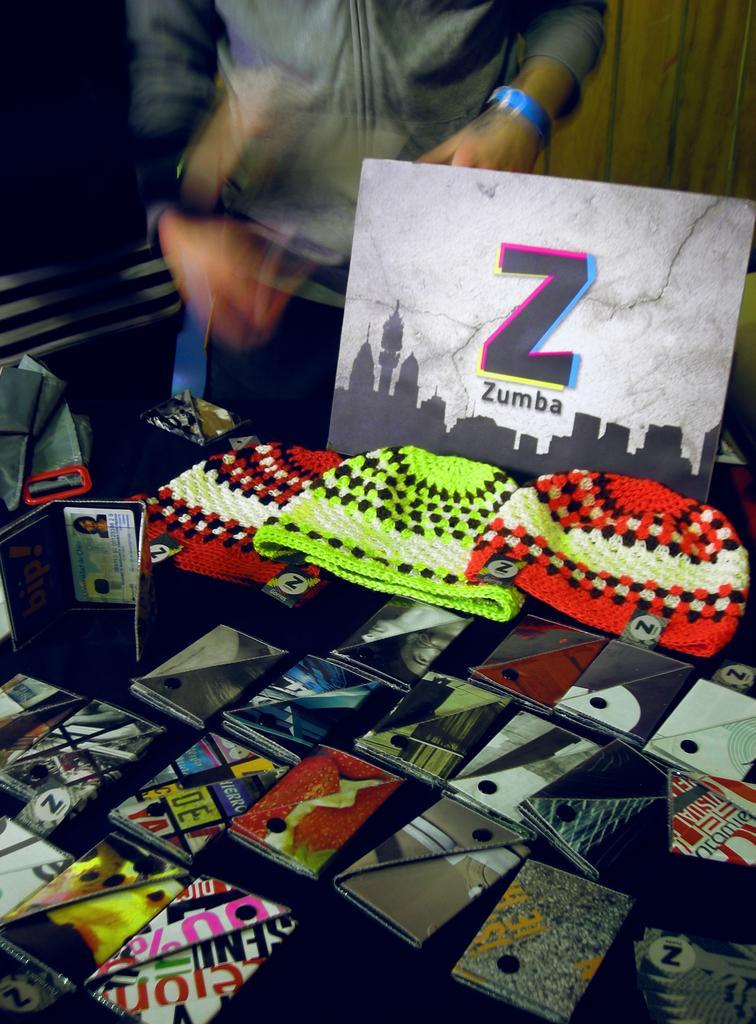In one or two sentences, can you explain what this image depicts? There are some wallets and caps kept on a surface at the bottom of this image. There is one person standing at the top of this image. There is a wooden wall in the background. 